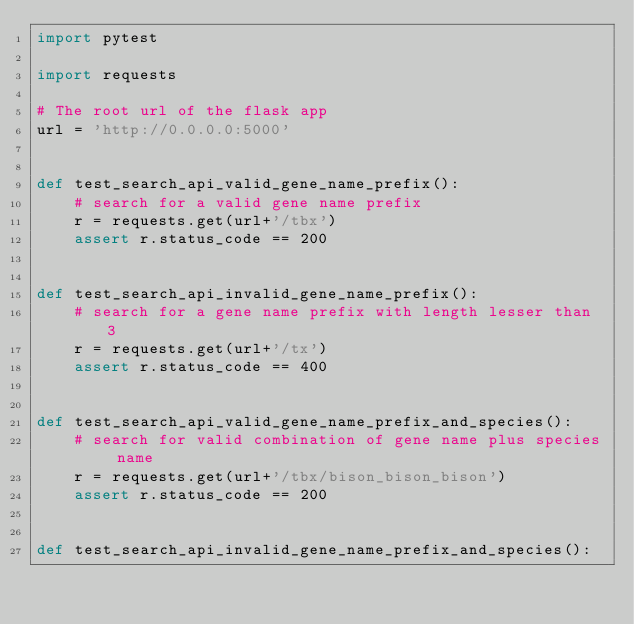<code> <loc_0><loc_0><loc_500><loc_500><_Python_>import pytest

import requests

# The root url of the flask app
url = 'http://0.0.0.0:5000'


def test_search_api_valid_gene_name_prefix():
    # search for a valid gene name prefix
    r = requests.get(url+'/tbx')
    assert r.status_code == 200


def test_search_api_invalid_gene_name_prefix():
    # search for a gene name prefix with length lesser than 3
    r = requests.get(url+'/tx')
    assert r.status_code == 400


def test_search_api_valid_gene_name_prefix_and_species():
    # search for valid combination of gene name plus species name
    r = requests.get(url+'/tbx/bison_bison_bison')
    assert r.status_code == 200


def test_search_api_invalid_gene_name_prefix_and_species():</code> 